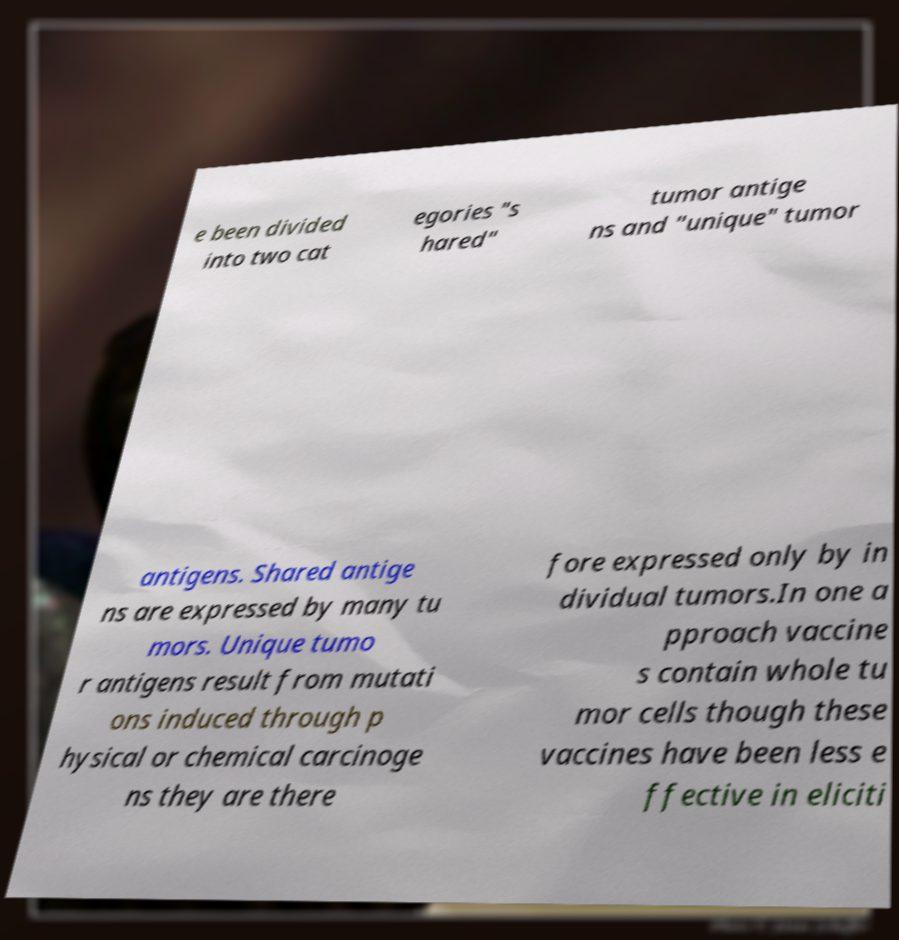Could you assist in decoding the text presented in this image and type it out clearly? e been divided into two cat egories "s hared" tumor antige ns and "unique" tumor antigens. Shared antige ns are expressed by many tu mors. Unique tumo r antigens result from mutati ons induced through p hysical or chemical carcinoge ns they are there fore expressed only by in dividual tumors.In one a pproach vaccine s contain whole tu mor cells though these vaccines have been less e ffective in eliciti 